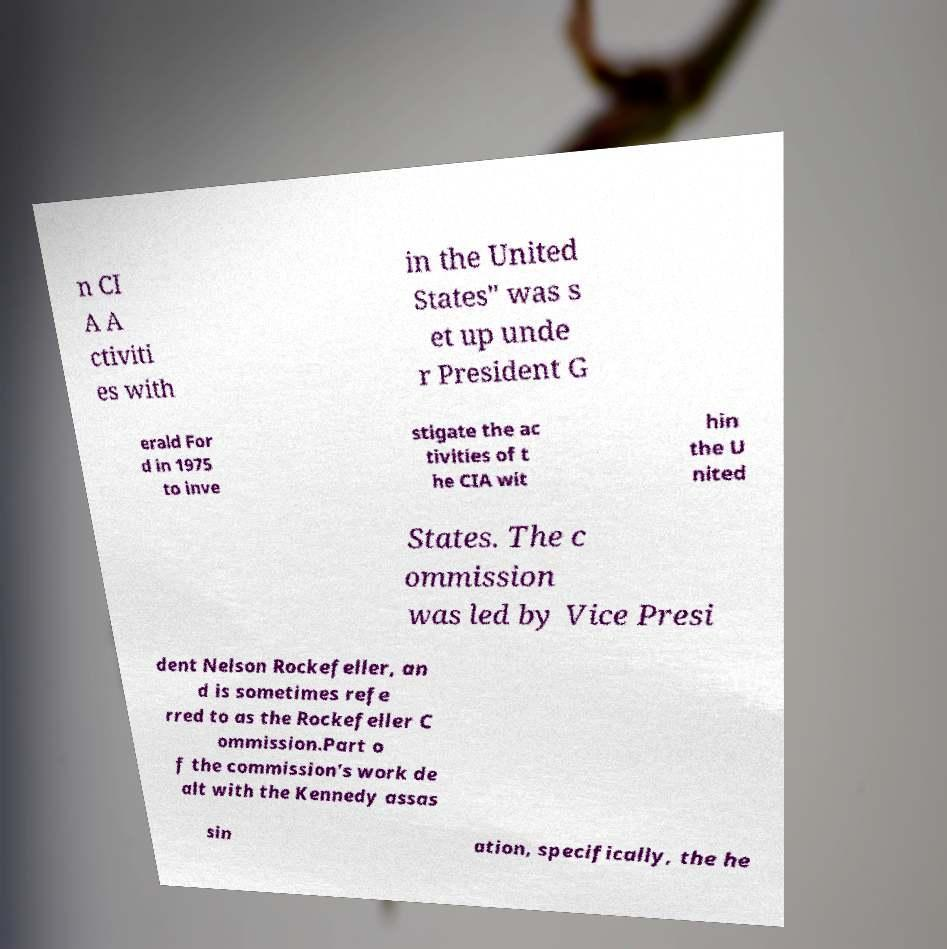Please identify and transcribe the text found in this image. n CI A A ctiviti es with in the United States" was s et up unde r President G erald For d in 1975 to inve stigate the ac tivities of t he CIA wit hin the U nited States. The c ommission was led by Vice Presi dent Nelson Rockefeller, an d is sometimes refe rred to as the Rockefeller C ommission.Part o f the commission's work de alt with the Kennedy assas sin ation, specifically, the he 